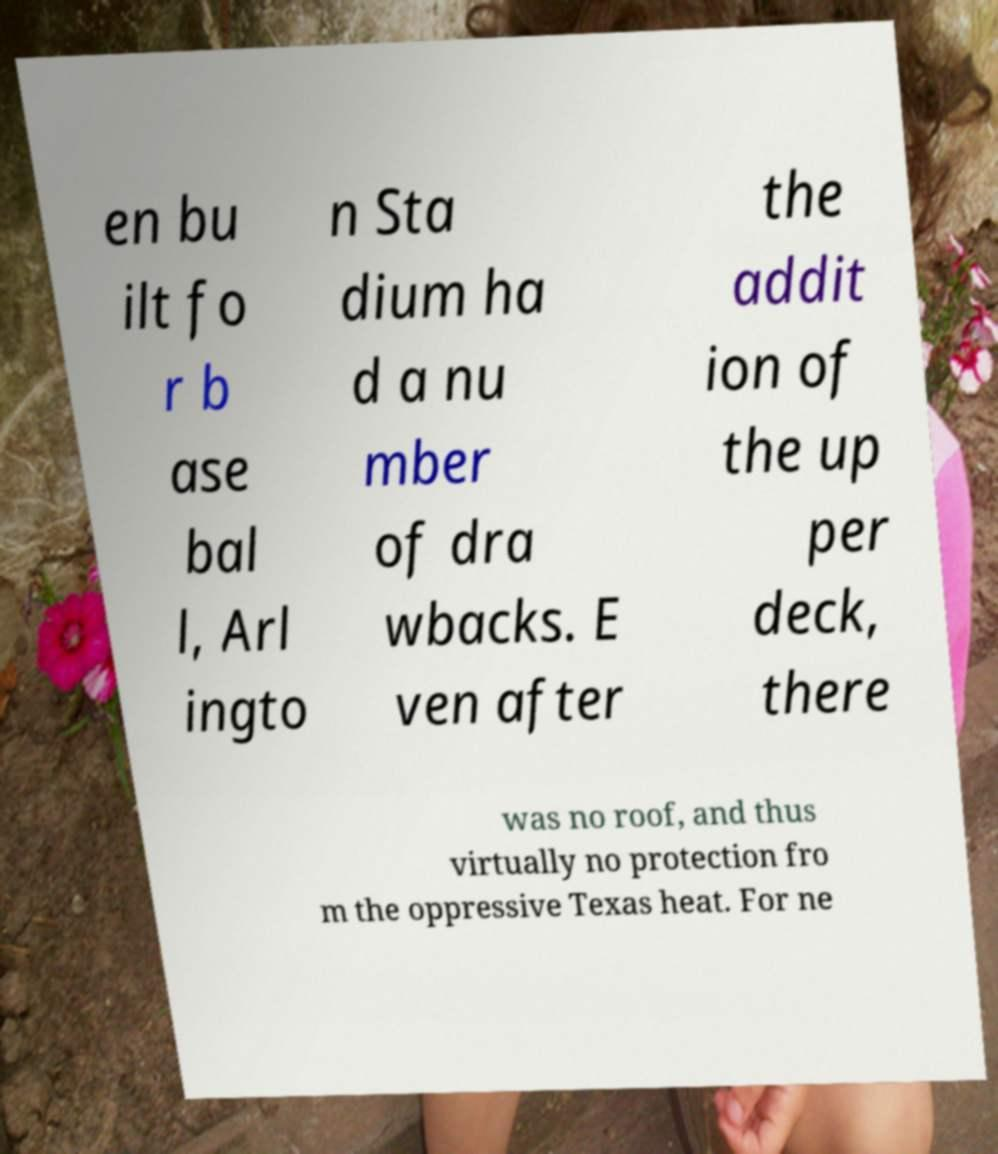Can you accurately transcribe the text from the provided image for me? en bu ilt fo r b ase bal l, Arl ingto n Sta dium ha d a nu mber of dra wbacks. E ven after the addit ion of the up per deck, there was no roof, and thus virtually no protection fro m the oppressive Texas heat. For ne 